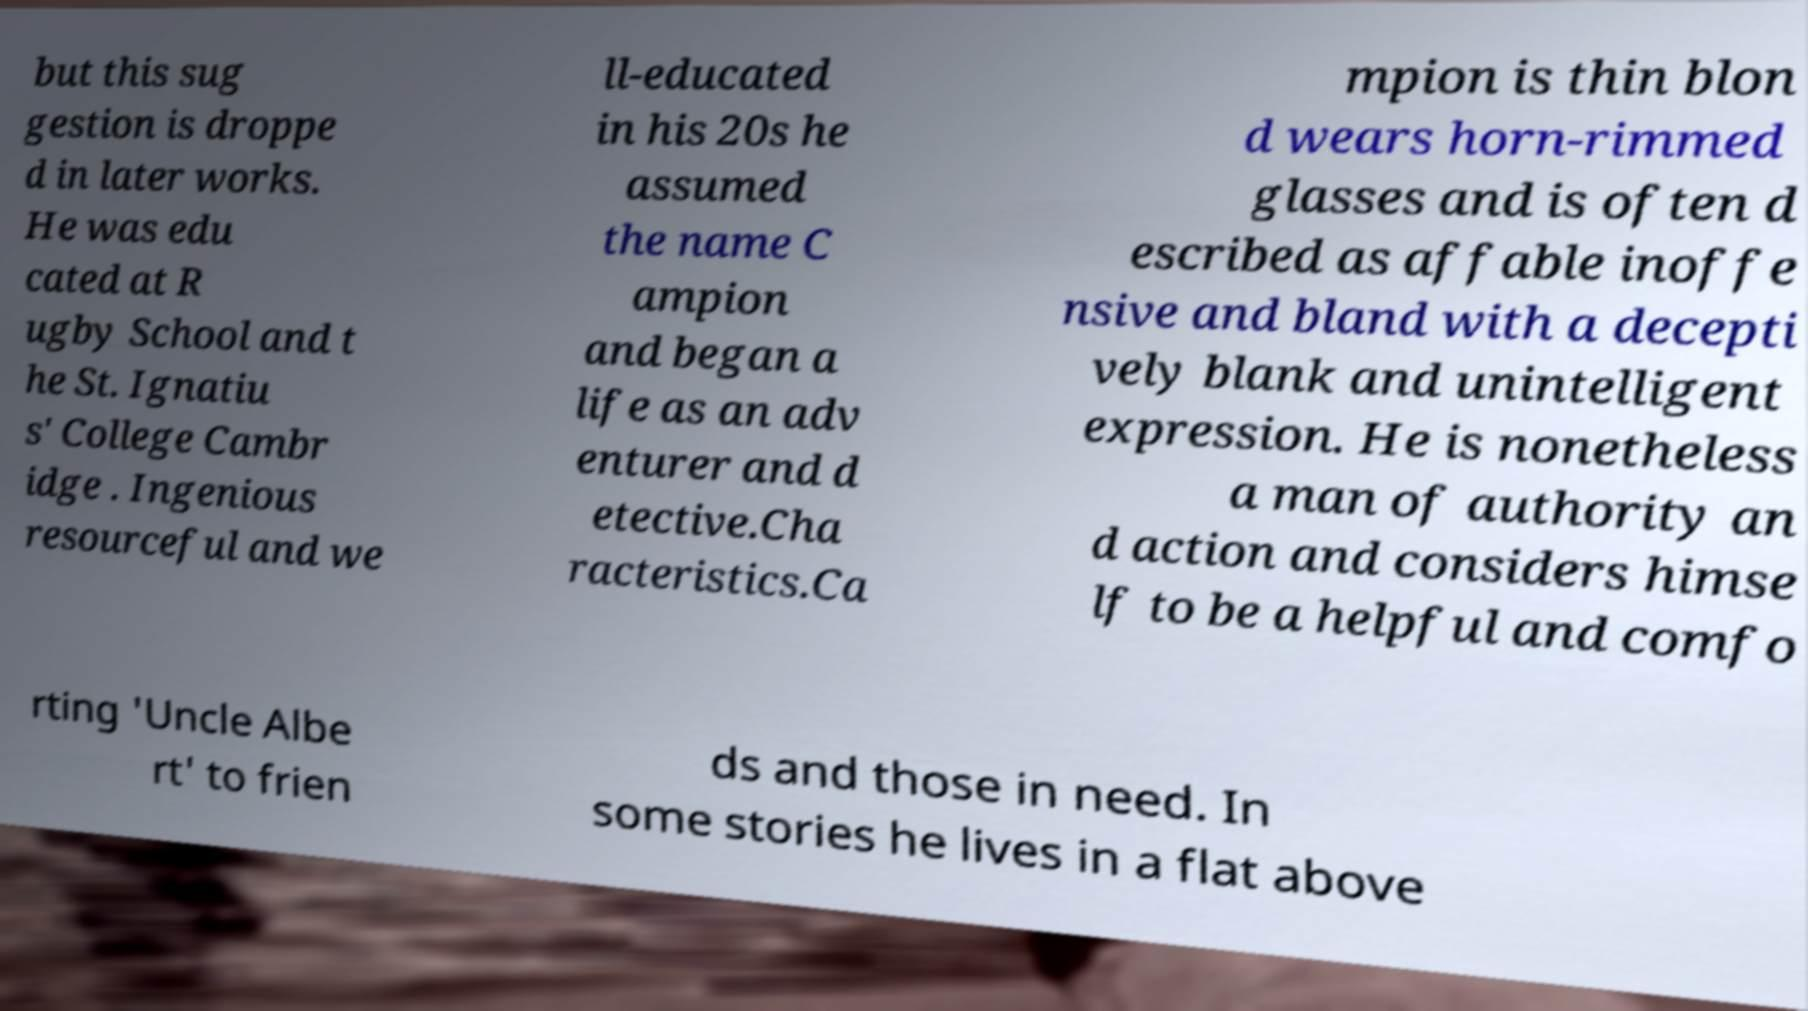I need the written content from this picture converted into text. Can you do that? but this sug gestion is droppe d in later works. He was edu cated at R ugby School and t he St. Ignatiu s' College Cambr idge . Ingenious resourceful and we ll-educated in his 20s he assumed the name C ampion and began a life as an adv enturer and d etective.Cha racteristics.Ca mpion is thin blon d wears horn-rimmed glasses and is often d escribed as affable inoffe nsive and bland with a decepti vely blank and unintelligent expression. He is nonetheless a man of authority an d action and considers himse lf to be a helpful and comfo rting 'Uncle Albe rt' to frien ds and those in need. In some stories he lives in a flat above 